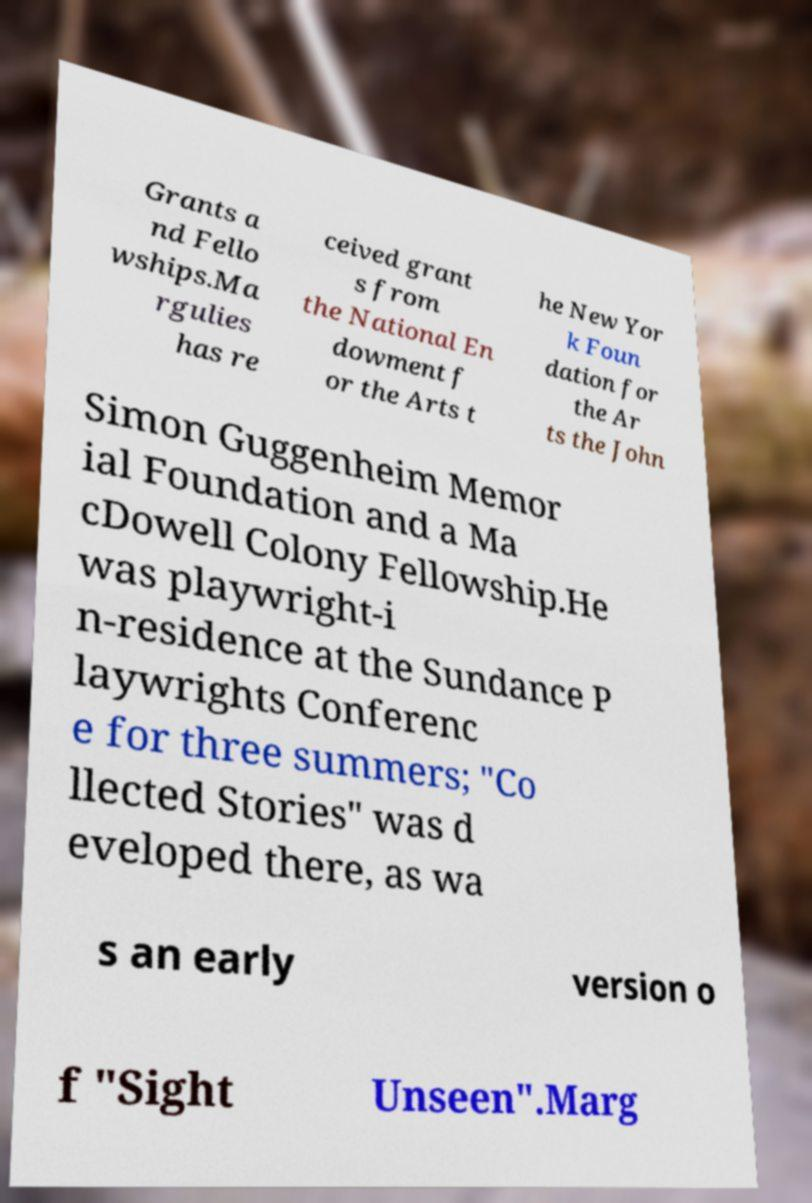Can you accurately transcribe the text from the provided image for me? Grants a nd Fello wships.Ma rgulies has re ceived grant s from the National En dowment f or the Arts t he New Yor k Foun dation for the Ar ts the John Simon Guggenheim Memor ial Foundation and a Ma cDowell Colony Fellowship.He was playwright-i n-residence at the Sundance P laywrights Conferenc e for three summers; "Co llected Stories" was d eveloped there, as wa s an early version o f "Sight Unseen".Marg 